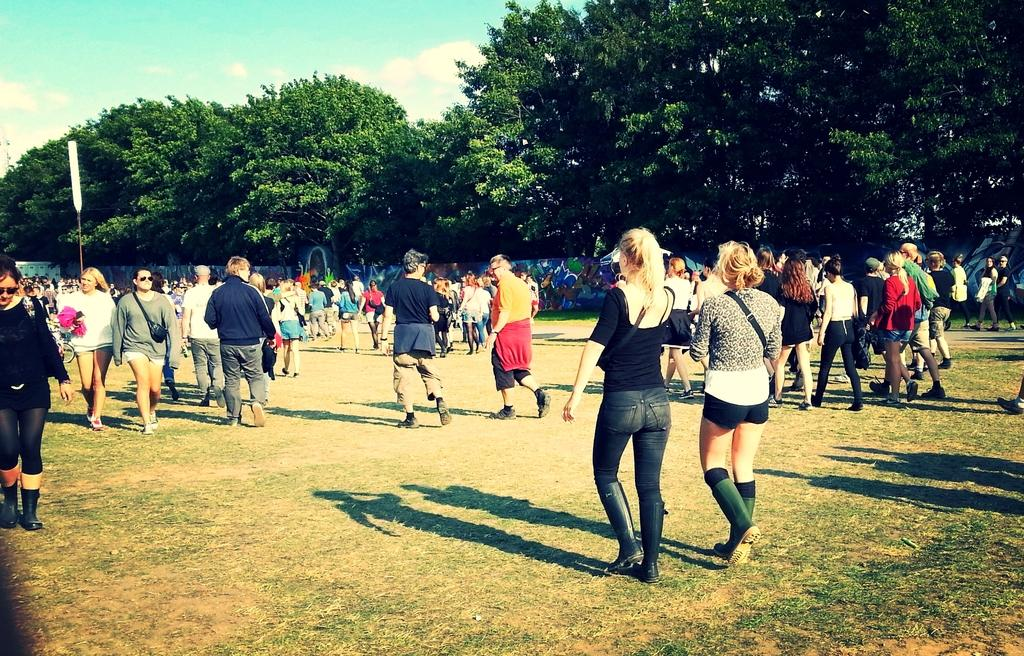What are the people in the image doing? There are many people walking on the ground in the image. What type of surface are the people walking on? The ground has grass on it. What can be seen in the background of the image? There are trees and a wall in the background of the image. What is visible at the top of the image? The sky is visible at the top of the image. What type of waves can be seen crashing on the shore in the image? There are no waves or shore present in the image; it features people walking on grassy ground with trees and a wall in the background. 